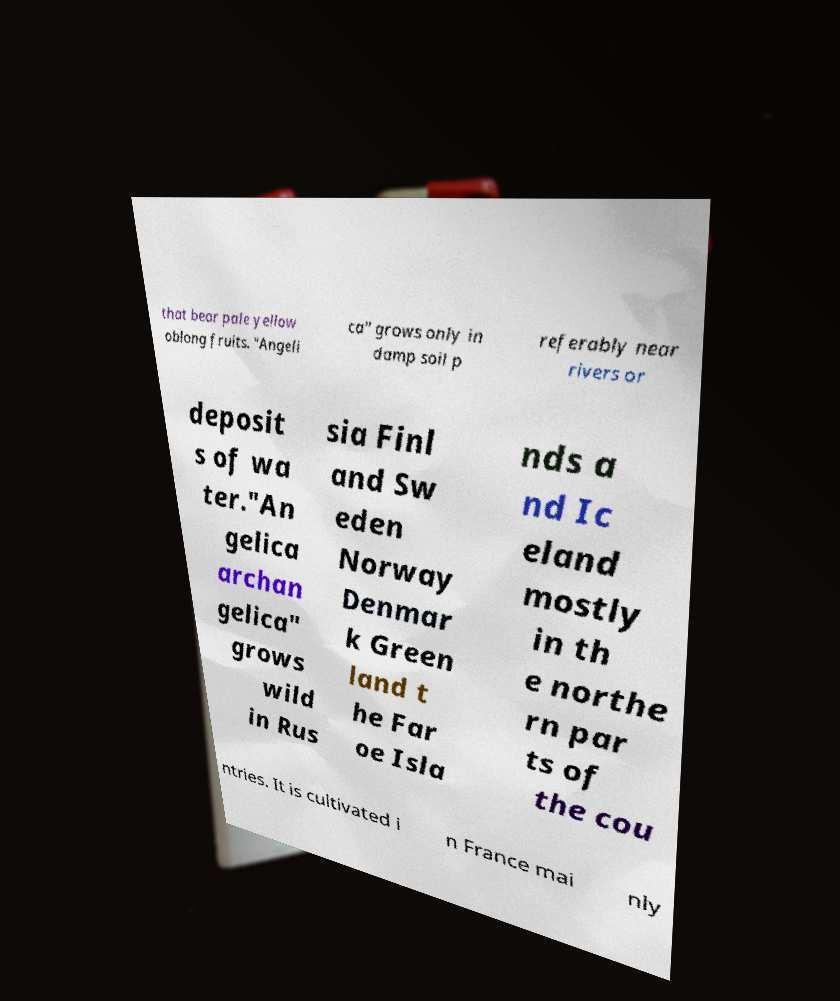There's text embedded in this image that I need extracted. Can you transcribe it verbatim? that bear pale yellow oblong fruits. "Angeli ca" grows only in damp soil p referably near rivers or deposit s of wa ter."An gelica archan gelica" grows wild in Rus sia Finl and Sw eden Norway Denmar k Green land t he Far oe Isla nds a nd Ic eland mostly in th e northe rn par ts of the cou ntries. It is cultivated i n France mai nly 